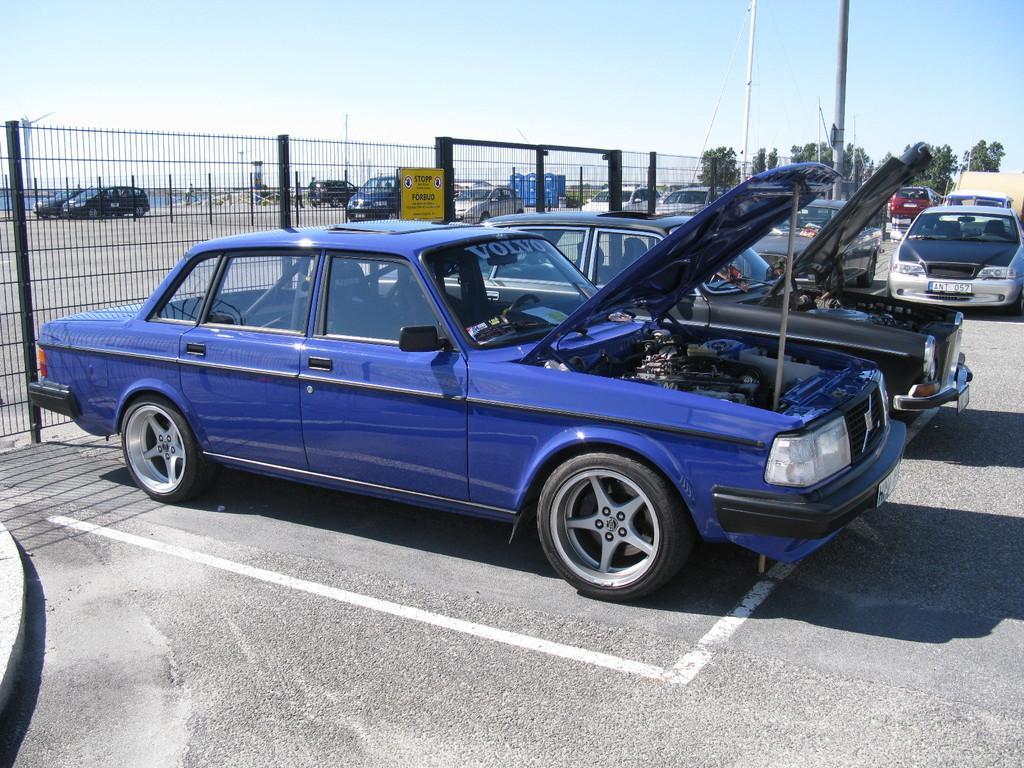How would you summarize this image in a sentence or two? In this picture I can see group of cars on the road. In the background I can see the sky, poles and fence. On the right side I can see trees. Here I can see white lines and shadows. 